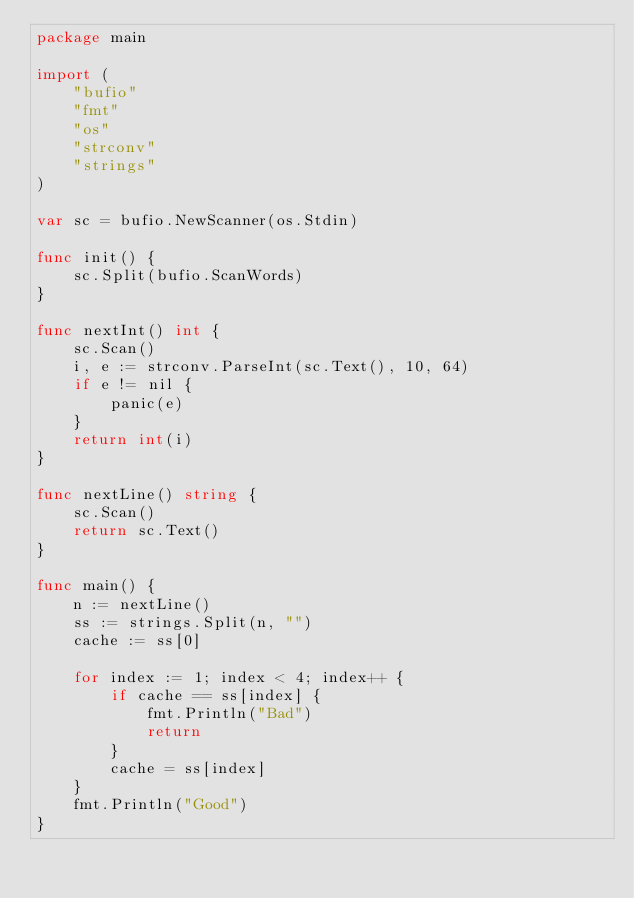<code> <loc_0><loc_0><loc_500><loc_500><_Go_>package main

import (
	"bufio"
	"fmt"
	"os"
	"strconv"
	"strings"
)

var sc = bufio.NewScanner(os.Stdin)

func init() {
	sc.Split(bufio.ScanWords)
}

func nextInt() int {
	sc.Scan()
	i, e := strconv.ParseInt(sc.Text(), 10, 64)
	if e != nil {
		panic(e)
	}
	return int(i)
}

func nextLine() string {
	sc.Scan()
	return sc.Text()
}

func main() {
	n := nextLine()
	ss := strings.Split(n, "")
	cache := ss[0]

	for index := 1; index < 4; index++ {
		if cache == ss[index] {
			fmt.Println("Bad")
			return
		}
		cache = ss[index]
	}
	fmt.Println("Good")
}
</code> 